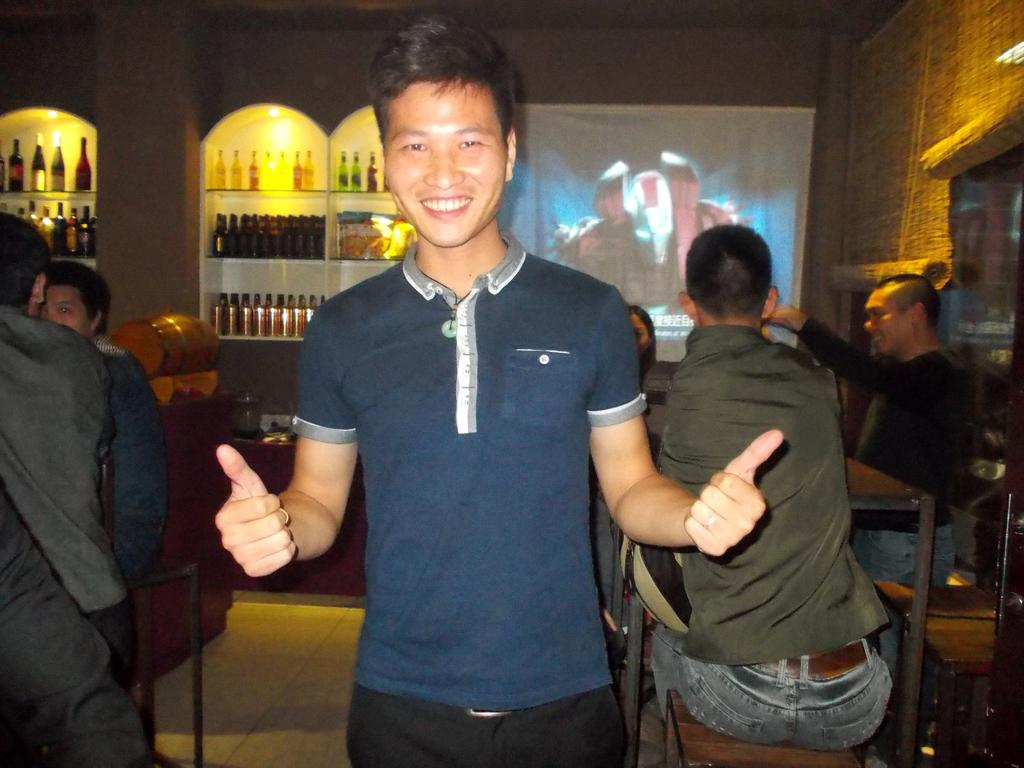What is the man in the image doing? There is a man standing in the image. What are the people at the table in the image doing? There are people sitting at a table in the image. What can be seen on the shelf in the image? There are many bottles on a shelf in the image. What type of mind-reading selection can be seen in the image? There is no mind-reading selection present in the image; it features a man standing, people sitting at a table, and bottles on a shelf. How many bits of information can be gathered from the image? The concept of "bits" is not applicable to the image, as it is a visual representation and not a digital file. 